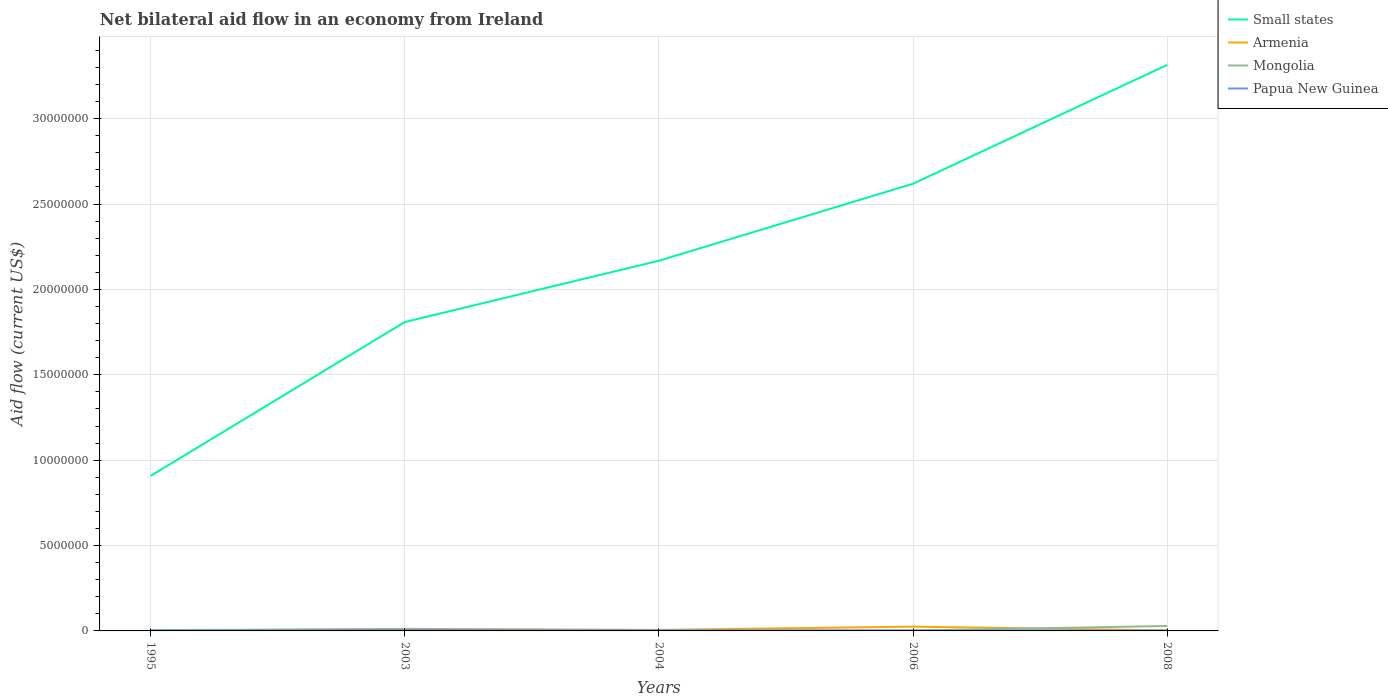Does the line corresponding to Papua New Guinea intersect with the line corresponding to Small states?
Provide a short and direct response. No. What is the difference between the highest and the lowest net bilateral aid flow in Mongolia?
Your response must be concise. 1. Is the net bilateral aid flow in Armenia strictly greater than the net bilateral aid flow in Small states over the years?
Offer a terse response. Yes. How many lines are there?
Provide a short and direct response. 4. How many years are there in the graph?
Provide a short and direct response. 5. Does the graph contain grids?
Offer a terse response. Yes. How are the legend labels stacked?
Offer a very short reply. Vertical. What is the title of the graph?
Give a very brief answer. Net bilateral aid flow in an economy from Ireland. Does "Low & middle income" appear as one of the legend labels in the graph?
Give a very brief answer. No. What is the Aid flow (current US$) of Small states in 1995?
Keep it short and to the point. 9.08e+06. What is the Aid flow (current US$) of Small states in 2003?
Ensure brevity in your answer.  1.81e+07. What is the Aid flow (current US$) in Armenia in 2003?
Offer a very short reply. 1.20e+05. What is the Aid flow (current US$) in Papua New Guinea in 2003?
Give a very brief answer. 6.00e+04. What is the Aid flow (current US$) in Small states in 2004?
Make the answer very short. 2.17e+07. What is the Aid flow (current US$) of Mongolia in 2004?
Keep it short and to the point. 3.00e+04. What is the Aid flow (current US$) of Small states in 2006?
Keep it short and to the point. 2.62e+07. What is the Aid flow (current US$) of Armenia in 2006?
Provide a short and direct response. 2.50e+05. What is the Aid flow (current US$) of Small states in 2008?
Keep it short and to the point. 3.32e+07. Across all years, what is the maximum Aid flow (current US$) of Small states?
Ensure brevity in your answer.  3.32e+07. Across all years, what is the maximum Aid flow (current US$) in Mongolia?
Offer a terse response. 2.90e+05. Across all years, what is the minimum Aid flow (current US$) in Small states?
Your answer should be compact. 9.08e+06. Across all years, what is the minimum Aid flow (current US$) of Mongolia?
Keep it short and to the point. 2.00e+04. What is the total Aid flow (current US$) in Small states in the graph?
Your response must be concise. 1.08e+08. What is the total Aid flow (current US$) in Armenia in the graph?
Your answer should be very brief. 4.80e+05. What is the total Aid flow (current US$) of Papua New Guinea in the graph?
Your answer should be compact. 1.60e+05. What is the difference between the Aid flow (current US$) of Small states in 1995 and that in 2003?
Give a very brief answer. -9.01e+06. What is the difference between the Aid flow (current US$) of Mongolia in 1995 and that in 2003?
Give a very brief answer. -4.00e+04. What is the difference between the Aid flow (current US$) in Small states in 1995 and that in 2004?
Provide a succinct answer. -1.26e+07. What is the difference between the Aid flow (current US$) of Armenia in 1995 and that in 2004?
Provide a succinct answer. -4.00e+04. What is the difference between the Aid flow (current US$) in Mongolia in 1995 and that in 2004?
Offer a terse response. 2.00e+04. What is the difference between the Aid flow (current US$) in Papua New Guinea in 1995 and that in 2004?
Give a very brief answer. -10000. What is the difference between the Aid flow (current US$) of Small states in 1995 and that in 2006?
Offer a very short reply. -1.71e+07. What is the difference between the Aid flow (current US$) in Papua New Guinea in 1995 and that in 2006?
Provide a short and direct response. -10000. What is the difference between the Aid flow (current US$) in Small states in 1995 and that in 2008?
Make the answer very short. -2.41e+07. What is the difference between the Aid flow (current US$) of Armenia in 1995 and that in 2008?
Provide a succinct answer. -10000. What is the difference between the Aid flow (current US$) of Mongolia in 1995 and that in 2008?
Give a very brief answer. -2.40e+05. What is the difference between the Aid flow (current US$) in Small states in 2003 and that in 2004?
Keep it short and to the point. -3.59e+06. What is the difference between the Aid flow (current US$) in Mongolia in 2003 and that in 2004?
Provide a succinct answer. 6.00e+04. What is the difference between the Aid flow (current US$) in Papua New Guinea in 2003 and that in 2004?
Provide a succinct answer. 3.00e+04. What is the difference between the Aid flow (current US$) in Small states in 2003 and that in 2006?
Offer a terse response. -8.10e+06. What is the difference between the Aid flow (current US$) in Armenia in 2003 and that in 2006?
Offer a terse response. -1.30e+05. What is the difference between the Aid flow (current US$) in Mongolia in 2003 and that in 2006?
Offer a terse response. 7.00e+04. What is the difference between the Aid flow (current US$) in Papua New Guinea in 2003 and that in 2006?
Give a very brief answer. 3.00e+04. What is the difference between the Aid flow (current US$) of Small states in 2003 and that in 2008?
Your answer should be compact. -1.51e+07. What is the difference between the Aid flow (current US$) in Mongolia in 2003 and that in 2008?
Ensure brevity in your answer.  -2.00e+05. What is the difference between the Aid flow (current US$) of Papua New Guinea in 2003 and that in 2008?
Offer a terse response. 4.00e+04. What is the difference between the Aid flow (current US$) in Small states in 2004 and that in 2006?
Provide a short and direct response. -4.51e+06. What is the difference between the Aid flow (current US$) in Mongolia in 2004 and that in 2006?
Make the answer very short. 10000. What is the difference between the Aid flow (current US$) of Small states in 2004 and that in 2008?
Provide a succinct answer. -1.15e+07. What is the difference between the Aid flow (current US$) of Mongolia in 2004 and that in 2008?
Give a very brief answer. -2.60e+05. What is the difference between the Aid flow (current US$) in Papua New Guinea in 2004 and that in 2008?
Offer a terse response. 10000. What is the difference between the Aid flow (current US$) of Small states in 2006 and that in 2008?
Offer a very short reply. -6.96e+06. What is the difference between the Aid flow (current US$) in Mongolia in 2006 and that in 2008?
Provide a succinct answer. -2.70e+05. What is the difference between the Aid flow (current US$) in Small states in 1995 and the Aid flow (current US$) in Armenia in 2003?
Offer a very short reply. 8.96e+06. What is the difference between the Aid flow (current US$) of Small states in 1995 and the Aid flow (current US$) of Mongolia in 2003?
Keep it short and to the point. 8.99e+06. What is the difference between the Aid flow (current US$) in Small states in 1995 and the Aid flow (current US$) in Papua New Guinea in 2003?
Offer a very short reply. 9.02e+06. What is the difference between the Aid flow (current US$) in Armenia in 1995 and the Aid flow (current US$) in Mongolia in 2003?
Provide a succinct answer. -7.00e+04. What is the difference between the Aid flow (current US$) of Small states in 1995 and the Aid flow (current US$) of Armenia in 2004?
Your answer should be very brief. 9.02e+06. What is the difference between the Aid flow (current US$) in Small states in 1995 and the Aid flow (current US$) in Mongolia in 2004?
Provide a succinct answer. 9.05e+06. What is the difference between the Aid flow (current US$) in Small states in 1995 and the Aid flow (current US$) in Papua New Guinea in 2004?
Your answer should be very brief. 9.05e+06. What is the difference between the Aid flow (current US$) of Small states in 1995 and the Aid flow (current US$) of Armenia in 2006?
Your response must be concise. 8.83e+06. What is the difference between the Aid flow (current US$) of Small states in 1995 and the Aid flow (current US$) of Mongolia in 2006?
Offer a terse response. 9.06e+06. What is the difference between the Aid flow (current US$) of Small states in 1995 and the Aid flow (current US$) of Papua New Guinea in 2006?
Your response must be concise. 9.05e+06. What is the difference between the Aid flow (current US$) of Armenia in 1995 and the Aid flow (current US$) of Papua New Guinea in 2006?
Offer a very short reply. -10000. What is the difference between the Aid flow (current US$) of Small states in 1995 and the Aid flow (current US$) of Armenia in 2008?
Your answer should be very brief. 9.05e+06. What is the difference between the Aid flow (current US$) of Small states in 1995 and the Aid flow (current US$) of Mongolia in 2008?
Offer a terse response. 8.79e+06. What is the difference between the Aid flow (current US$) in Small states in 1995 and the Aid flow (current US$) in Papua New Guinea in 2008?
Make the answer very short. 9.06e+06. What is the difference between the Aid flow (current US$) of Armenia in 1995 and the Aid flow (current US$) of Papua New Guinea in 2008?
Your answer should be compact. 0. What is the difference between the Aid flow (current US$) of Small states in 2003 and the Aid flow (current US$) of Armenia in 2004?
Offer a terse response. 1.80e+07. What is the difference between the Aid flow (current US$) of Small states in 2003 and the Aid flow (current US$) of Mongolia in 2004?
Your answer should be very brief. 1.81e+07. What is the difference between the Aid flow (current US$) in Small states in 2003 and the Aid flow (current US$) in Papua New Guinea in 2004?
Your response must be concise. 1.81e+07. What is the difference between the Aid flow (current US$) in Small states in 2003 and the Aid flow (current US$) in Armenia in 2006?
Ensure brevity in your answer.  1.78e+07. What is the difference between the Aid flow (current US$) of Small states in 2003 and the Aid flow (current US$) of Mongolia in 2006?
Ensure brevity in your answer.  1.81e+07. What is the difference between the Aid flow (current US$) of Small states in 2003 and the Aid flow (current US$) of Papua New Guinea in 2006?
Ensure brevity in your answer.  1.81e+07. What is the difference between the Aid flow (current US$) in Armenia in 2003 and the Aid flow (current US$) in Papua New Guinea in 2006?
Keep it short and to the point. 9.00e+04. What is the difference between the Aid flow (current US$) of Small states in 2003 and the Aid flow (current US$) of Armenia in 2008?
Provide a succinct answer. 1.81e+07. What is the difference between the Aid flow (current US$) in Small states in 2003 and the Aid flow (current US$) in Mongolia in 2008?
Make the answer very short. 1.78e+07. What is the difference between the Aid flow (current US$) of Small states in 2003 and the Aid flow (current US$) of Papua New Guinea in 2008?
Provide a short and direct response. 1.81e+07. What is the difference between the Aid flow (current US$) in Armenia in 2003 and the Aid flow (current US$) in Papua New Guinea in 2008?
Make the answer very short. 1.00e+05. What is the difference between the Aid flow (current US$) of Mongolia in 2003 and the Aid flow (current US$) of Papua New Guinea in 2008?
Provide a short and direct response. 7.00e+04. What is the difference between the Aid flow (current US$) of Small states in 2004 and the Aid flow (current US$) of Armenia in 2006?
Offer a very short reply. 2.14e+07. What is the difference between the Aid flow (current US$) of Small states in 2004 and the Aid flow (current US$) of Mongolia in 2006?
Provide a short and direct response. 2.17e+07. What is the difference between the Aid flow (current US$) in Small states in 2004 and the Aid flow (current US$) in Papua New Guinea in 2006?
Give a very brief answer. 2.16e+07. What is the difference between the Aid flow (current US$) in Armenia in 2004 and the Aid flow (current US$) in Papua New Guinea in 2006?
Offer a very short reply. 3.00e+04. What is the difference between the Aid flow (current US$) in Mongolia in 2004 and the Aid flow (current US$) in Papua New Guinea in 2006?
Give a very brief answer. 0. What is the difference between the Aid flow (current US$) of Small states in 2004 and the Aid flow (current US$) of Armenia in 2008?
Give a very brief answer. 2.16e+07. What is the difference between the Aid flow (current US$) of Small states in 2004 and the Aid flow (current US$) of Mongolia in 2008?
Offer a terse response. 2.14e+07. What is the difference between the Aid flow (current US$) in Small states in 2004 and the Aid flow (current US$) in Papua New Guinea in 2008?
Your answer should be very brief. 2.17e+07. What is the difference between the Aid flow (current US$) of Armenia in 2004 and the Aid flow (current US$) of Mongolia in 2008?
Give a very brief answer. -2.30e+05. What is the difference between the Aid flow (current US$) of Armenia in 2004 and the Aid flow (current US$) of Papua New Guinea in 2008?
Provide a short and direct response. 4.00e+04. What is the difference between the Aid flow (current US$) of Small states in 2006 and the Aid flow (current US$) of Armenia in 2008?
Ensure brevity in your answer.  2.62e+07. What is the difference between the Aid flow (current US$) in Small states in 2006 and the Aid flow (current US$) in Mongolia in 2008?
Your answer should be compact. 2.59e+07. What is the difference between the Aid flow (current US$) of Small states in 2006 and the Aid flow (current US$) of Papua New Guinea in 2008?
Ensure brevity in your answer.  2.62e+07. What is the difference between the Aid flow (current US$) of Armenia in 2006 and the Aid flow (current US$) of Papua New Guinea in 2008?
Ensure brevity in your answer.  2.30e+05. What is the average Aid flow (current US$) of Small states per year?
Your answer should be very brief. 2.16e+07. What is the average Aid flow (current US$) in Armenia per year?
Your answer should be compact. 9.60e+04. What is the average Aid flow (current US$) of Mongolia per year?
Offer a very short reply. 9.60e+04. What is the average Aid flow (current US$) in Papua New Guinea per year?
Make the answer very short. 3.20e+04. In the year 1995, what is the difference between the Aid flow (current US$) in Small states and Aid flow (current US$) in Armenia?
Offer a very short reply. 9.06e+06. In the year 1995, what is the difference between the Aid flow (current US$) in Small states and Aid flow (current US$) in Mongolia?
Offer a terse response. 9.03e+06. In the year 1995, what is the difference between the Aid flow (current US$) in Small states and Aid flow (current US$) in Papua New Guinea?
Provide a succinct answer. 9.06e+06. In the year 1995, what is the difference between the Aid flow (current US$) of Armenia and Aid flow (current US$) of Papua New Guinea?
Ensure brevity in your answer.  0. In the year 2003, what is the difference between the Aid flow (current US$) of Small states and Aid flow (current US$) of Armenia?
Your answer should be very brief. 1.80e+07. In the year 2003, what is the difference between the Aid flow (current US$) of Small states and Aid flow (current US$) of Mongolia?
Give a very brief answer. 1.80e+07. In the year 2003, what is the difference between the Aid flow (current US$) in Small states and Aid flow (current US$) in Papua New Guinea?
Give a very brief answer. 1.80e+07. In the year 2003, what is the difference between the Aid flow (current US$) of Armenia and Aid flow (current US$) of Papua New Guinea?
Keep it short and to the point. 6.00e+04. In the year 2003, what is the difference between the Aid flow (current US$) in Mongolia and Aid flow (current US$) in Papua New Guinea?
Keep it short and to the point. 3.00e+04. In the year 2004, what is the difference between the Aid flow (current US$) in Small states and Aid flow (current US$) in Armenia?
Provide a succinct answer. 2.16e+07. In the year 2004, what is the difference between the Aid flow (current US$) of Small states and Aid flow (current US$) of Mongolia?
Your response must be concise. 2.16e+07. In the year 2004, what is the difference between the Aid flow (current US$) of Small states and Aid flow (current US$) of Papua New Guinea?
Offer a very short reply. 2.16e+07. In the year 2004, what is the difference between the Aid flow (current US$) in Armenia and Aid flow (current US$) in Papua New Guinea?
Offer a very short reply. 3.00e+04. In the year 2006, what is the difference between the Aid flow (current US$) of Small states and Aid flow (current US$) of Armenia?
Keep it short and to the point. 2.59e+07. In the year 2006, what is the difference between the Aid flow (current US$) of Small states and Aid flow (current US$) of Mongolia?
Give a very brief answer. 2.62e+07. In the year 2006, what is the difference between the Aid flow (current US$) of Small states and Aid flow (current US$) of Papua New Guinea?
Your answer should be compact. 2.62e+07. In the year 2006, what is the difference between the Aid flow (current US$) of Armenia and Aid flow (current US$) of Mongolia?
Offer a terse response. 2.30e+05. In the year 2006, what is the difference between the Aid flow (current US$) of Mongolia and Aid flow (current US$) of Papua New Guinea?
Your answer should be very brief. -10000. In the year 2008, what is the difference between the Aid flow (current US$) in Small states and Aid flow (current US$) in Armenia?
Offer a terse response. 3.31e+07. In the year 2008, what is the difference between the Aid flow (current US$) in Small states and Aid flow (current US$) in Mongolia?
Ensure brevity in your answer.  3.29e+07. In the year 2008, what is the difference between the Aid flow (current US$) in Small states and Aid flow (current US$) in Papua New Guinea?
Keep it short and to the point. 3.31e+07. In the year 2008, what is the difference between the Aid flow (current US$) of Armenia and Aid flow (current US$) of Mongolia?
Offer a terse response. -2.60e+05. What is the ratio of the Aid flow (current US$) in Small states in 1995 to that in 2003?
Ensure brevity in your answer.  0.5. What is the ratio of the Aid flow (current US$) in Armenia in 1995 to that in 2003?
Make the answer very short. 0.17. What is the ratio of the Aid flow (current US$) in Mongolia in 1995 to that in 2003?
Your answer should be compact. 0.56. What is the ratio of the Aid flow (current US$) of Papua New Guinea in 1995 to that in 2003?
Give a very brief answer. 0.33. What is the ratio of the Aid flow (current US$) in Small states in 1995 to that in 2004?
Ensure brevity in your answer.  0.42. What is the ratio of the Aid flow (current US$) of Papua New Guinea in 1995 to that in 2004?
Give a very brief answer. 0.67. What is the ratio of the Aid flow (current US$) of Small states in 1995 to that in 2006?
Provide a succinct answer. 0.35. What is the ratio of the Aid flow (current US$) in Mongolia in 1995 to that in 2006?
Your answer should be compact. 2.5. What is the ratio of the Aid flow (current US$) in Small states in 1995 to that in 2008?
Provide a succinct answer. 0.27. What is the ratio of the Aid flow (current US$) in Mongolia in 1995 to that in 2008?
Provide a succinct answer. 0.17. What is the ratio of the Aid flow (current US$) of Papua New Guinea in 1995 to that in 2008?
Give a very brief answer. 1. What is the ratio of the Aid flow (current US$) of Small states in 2003 to that in 2004?
Your answer should be compact. 0.83. What is the ratio of the Aid flow (current US$) of Mongolia in 2003 to that in 2004?
Offer a very short reply. 3. What is the ratio of the Aid flow (current US$) in Small states in 2003 to that in 2006?
Provide a short and direct response. 0.69. What is the ratio of the Aid flow (current US$) of Armenia in 2003 to that in 2006?
Provide a succinct answer. 0.48. What is the ratio of the Aid flow (current US$) of Small states in 2003 to that in 2008?
Your response must be concise. 0.55. What is the ratio of the Aid flow (current US$) in Mongolia in 2003 to that in 2008?
Provide a succinct answer. 0.31. What is the ratio of the Aid flow (current US$) of Small states in 2004 to that in 2006?
Offer a terse response. 0.83. What is the ratio of the Aid flow (current US$) in Armenia in 2004 to that in 2006?
Offer a terse response. 0.24. What is the ratio of the Aid flow (current US$) in Small states in 2004 to that in 2008?
Give a very brief answer. 0.65. What is the ratio of the Aid flow (current US$) in Armenia in 2004 to that in 2008?
Ensure brevity in your answer.  2. What is the ratio of the Aid flow (current US$) of Mongolia in 2004 to that in 2008?
Provide a short and direct response. 0.1. What is the ratio of the Aid flow (current US$) of Small states in 2006 to that in 2008?
Offer a terse response. 0.79. What is the ratio of the Aid flow (current US$) of Armenia in 2006 to that in 2008?
Keep it short and to the point. 8.33. What is the ratio of the Aid flow (current US$) in Mongolia in 2006 to that in 2008?
Offer a terse response. 0.07. What is the difference between the highest and the second highest Aid flow (current US$) in Small states?
Your response must be concise. 6.96e+06. What is the difference between the highest and the second highest Aid flow (current US$) of Mongolia?
Offer a terse response. 2.00e+05. What is the difference between the highest and the second highest Aid flow (current US$) of Papua New Guinea?
Offer a very short reply. 3.00e+04. What is the difference between the highest and the lowest Aid flow (current US$) in Small states?
Your response must be concise. 2.41e+07. What is the difference between the highest and the lowest Aid flow (current US$) of Armenia?
Provide a succinct answer. 2.30e+05. What is the difference between the highest and the lowest Aid flow (current US$) of Mongolia?
Offer a very short reply. 2.70e+05. 